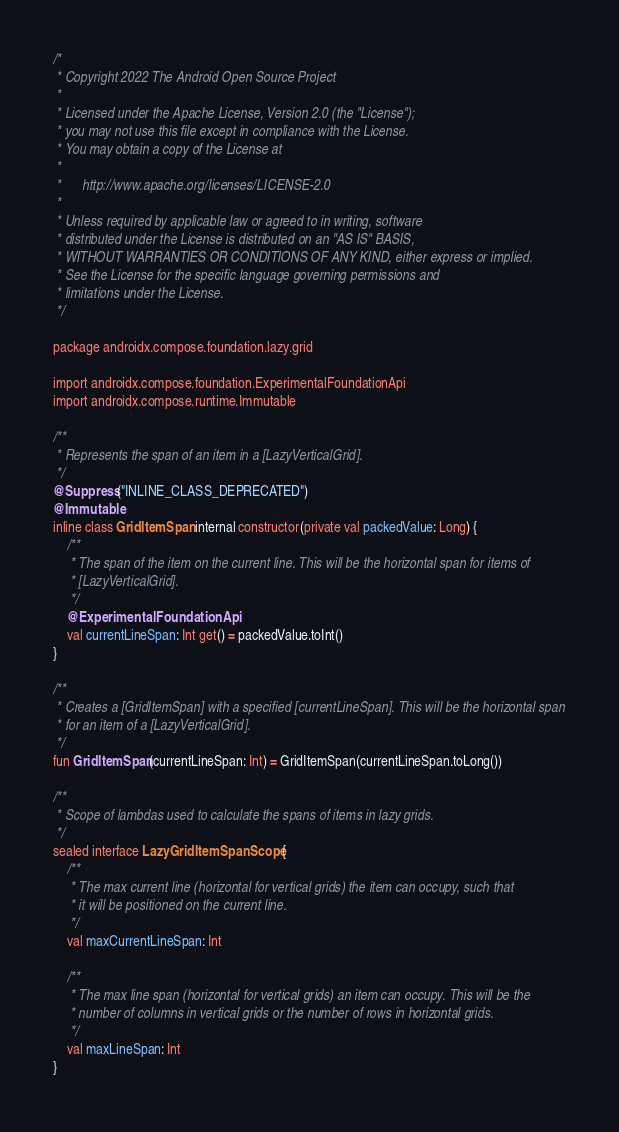<code> <loc_0><loc_0><loc_500><loc_500><_Kotlin_>/*
 * Copyright 2022 The Android Open Source Project
 *
 * Licensed under the Apache License, Version 2.0 (the "License");
 * you may not use this file except in compliance with the License.
 * You may obtain a copy of the License at
 *
 *      http://www.apache.org/licenses/LICENSE-2.0
 *
 * Unless required by applicable law or agreed to in writing, software
 * distributed under the License is distributed on an "AS IS" BASIS,
 * WITHOUT WARRANTIES OR CONDITIONS OF ANY KIND, either express or implied.
 * See the License for the specific language governing permissions and
 * limitations under the License.
 */

package androidx.compose.foundation.lazy.grid

import androidx.compose.foundation.ExperimentalFoundationApi
import androidx.compose.runtime.Immutable

/**
 * Represents the span of an item in a [LazyVerticalGrid].
 */
@Suppress("INLINE_CLASS_DEPRECATED")
@Immutable
inline class GridItemSpan internal constructor(private val packedValue: Long) {
    /**
     * The span of the item on the current line. This will be the horizontal span for items of
     * [LazyVerticalGrid].
     */
    @ExperimentalFoundationApi
    val currentLineSpan: Int get() = packedValue.toInt()
}

/**
 * Creates a [GridItemSpan] with a specified [currentLineSpan]. This will be the horizontal span
 * for an item of a [LazyVerticalGrid].
 */
fun GridItemSpan(currentLineSpan: Int) = GridItemSpan(currentLineSpan.toLong())

/**
 * Scope of lambdas used to calculate the spans of items in lazy grids.
 */
sealed interface LazyGridItemSpanScope {
    /**
     * The max current line (horizontal for vertical grids) the item can occupy, such that
     * it will be positioned on the current line.
     */
    val maxCurrentLineSpan: Int

    /**
     * The max line span (horizontal for vertical grids) an item can occupy. This will be the
     * number of columns in vertical grids or the number of rows in horizontal grids.
     */
    val maxLineSpan: Int
}
</code> 